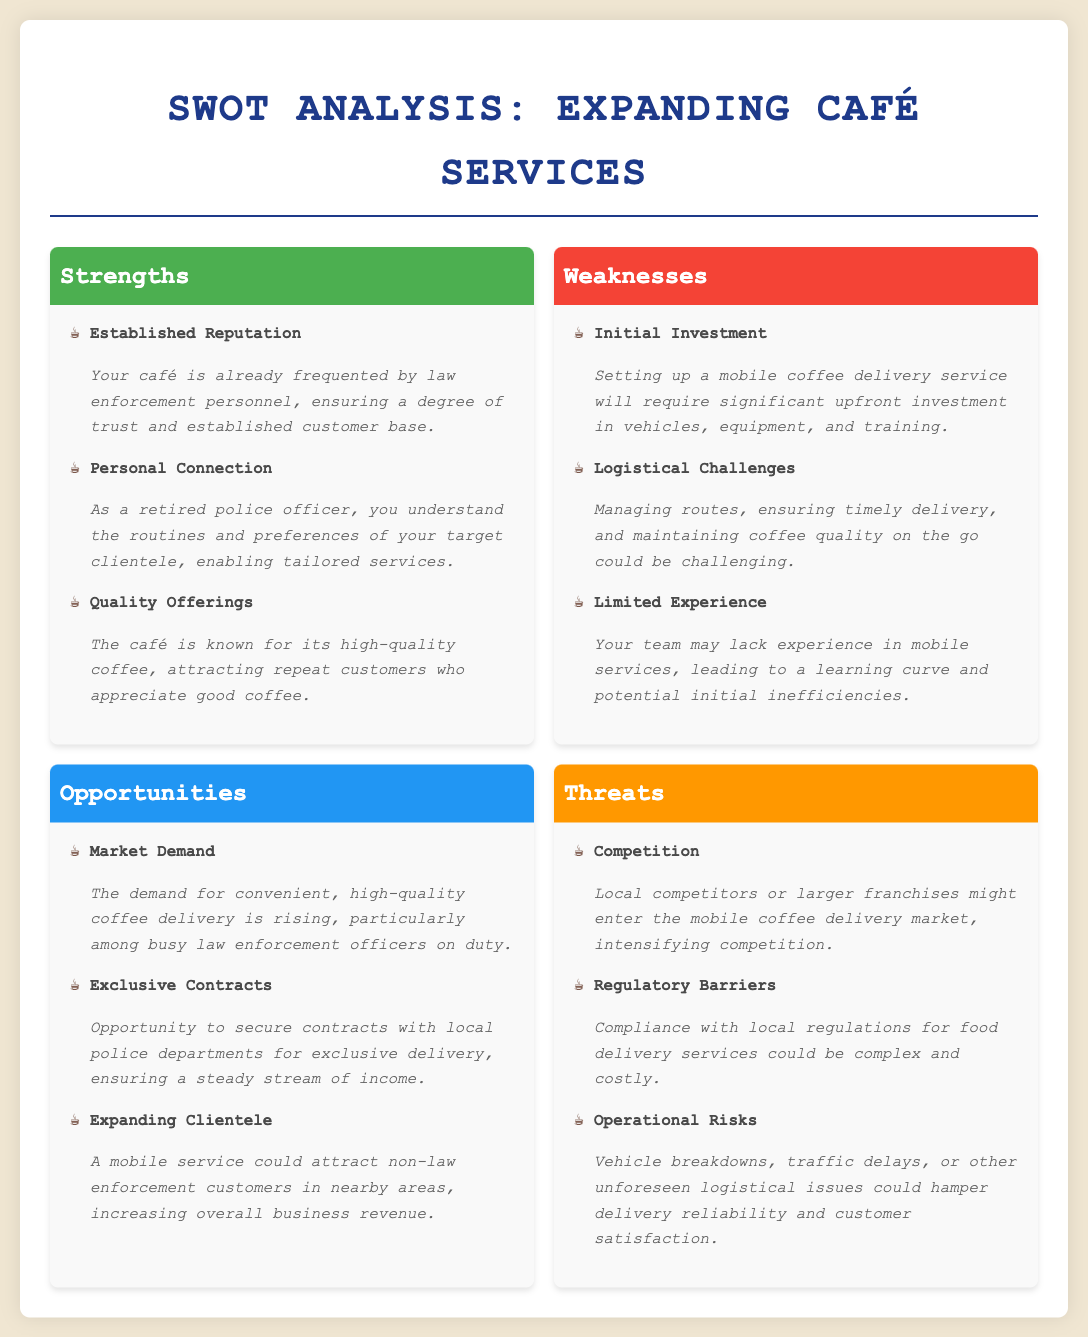What are the strengths listed? The strengths section lists specific strengths of expanding café services, including established reputation, personal connection, and quality offerings.
Answer: Established Reputation, Personal Connection, Quality Offerings What is the primary weakness related to financials? The weaknesses section highlights initial investment as a significant financial concern for setting up a mobile coffee delivery service.
Answer: Initial Investment Which opportunity entails securing contracts? The opportunities include the prospect of securing contracts with local police departments, which can provide a steady revenue stream.
Answer: Exclusive Contracts What is a noted threat involving competition? The threats section mentions the possibility of local competitors or larger franchises entering the market, which could intensify competition.
Answer: Competition How many weaknesses are mentioned in total? The weaknesses section outlines three distinct weaknesses, making it a total of three.
Answer: 3 What aspect of delivery is highlighted as a logistical challenge? One logistical challenge noted is managing delivery routes and ensuring timely service while maintaining coffee quality.
Answer: Logistical Challenges What market demand is addressed in the opportunities section? The opportunities highlight the rising demand for convenient, high-quality coffee delivery specifically for law enforcement personnel on duty.
Answer: Market Demand How do personal connections benefit the café? The strength section states that your personal connection helps in understanding client routines and preferences, which aids in service tailoring.
Answer: Personal Connection What operational risk is mentioned? The threats section lists vehicle breakdowns as a potential operational risk that could affect delivery reliability.
Answer: Vehicle breakdowns 